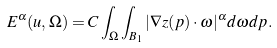Convert formula to latex. <formula><loc_0><loc_0><loc_500><loc_500>E ^ { \alpha } ( u , \Omega ) = C \int _ { \Omega } \int _ { B _ { 1 } } | \nabla z ( p ) \cdot \omega | ^ { \alpha } d \omega d p .</formula> 